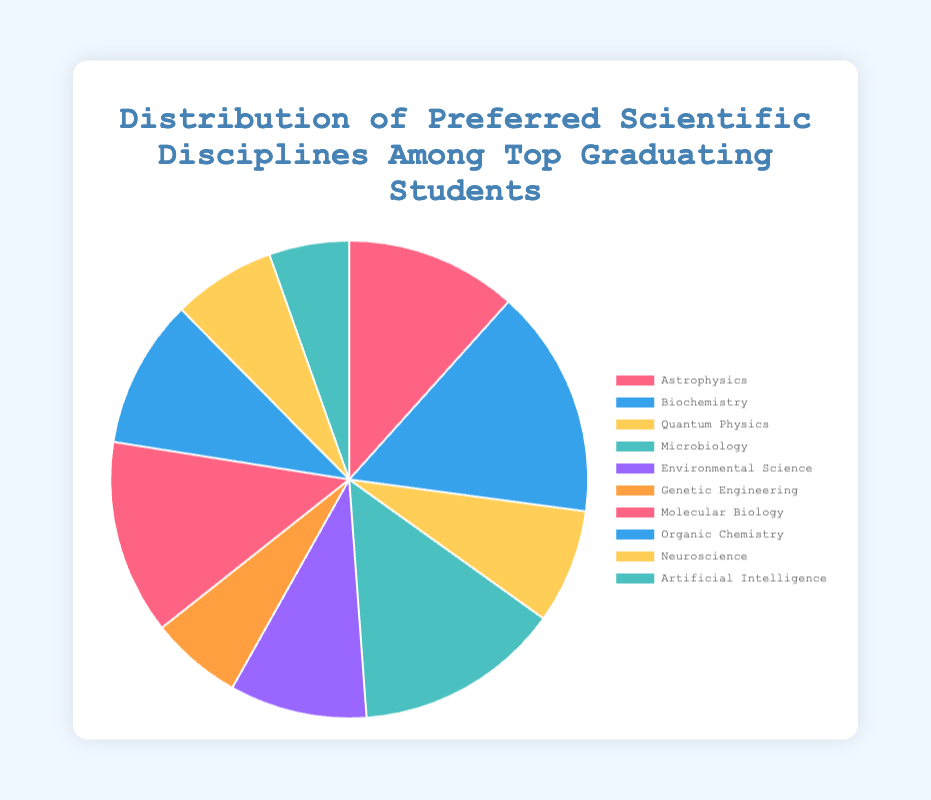Which scientific discipline has the largest number of top graduating students? Look at the pie chart to see which segment is the largest. The largest segment corresponds to Biochemistry with 20 top graduating students.
Answer: Biochemistry How many more students prefer Biochemistry over Astrophysics? Biochemistry has 20 students, and Astrophysics has 15. The difference is 20 - 15 = 5 students.
Answer: 5 What is the total number of top graduating students in Quantum Physics, Genetic Engineering, and Artificial Intelligence combined? Sum the number of students in these disciplines: Quantum Physics (10), Genetic Engineering (8), Artificial Intelligence (7). The total is 10 + 8 + 7 = 25 students.
Answer: 25 Which discipline has the smallest number of top graduating students? Identify the smallest segment on the pie chart. The smallest segment corresponds to Artificial Intelligence with 7 students.
Answer: Artificial Intelligence How many students prefer Environmental Science and Molecular Biology together? Add the number of students in Environmental Science (12) and Molecular Biology (17). The total is 12 + 17 = 29 students.
Answer: 29 Is the number of students in Microbiology greater or less than the number in Organic Chemistry? Compare the number of students in both disciplines: Microbiology (18) and Organic Chemistry (13). Microbiology has more students than Organic Chemistry.
Answer: Greater What percentage of the total do top graduating students in Neuroscience represent? Calculate the percentage: Neuroscience has 9 students out of a total of 129 (sum of all students in the chart). The percentage is (9 / 129) * 100 ≈ 6.98%.
Answer: Approximately 6.98% If Genetic Engineering and Artificial Intelligence were combined into one discipline, would it have more top graduating students than Molecular Biology? Combine the numbers: Genetic Engineering (8) + Artificial Intelligence (7) = 15; Molecular Biology has 17. Therefore, 15 < 17, so no, it would have fewer students.
Answer: No What is the difference in the number of top graduating students between Astrophysics and Molecular Biology? Calculate the difference: Astrophysics (15) and Molecular Biology (17). The difference is 17 - 15 = 2 students.
Answer: 2 Which two disciplines have a combined total number of top graduating students closest to 30? Look at the combinations: Microbiology (18) + Organic Chemistry (13) = 31, Environmental Science (12) + Molecular Biology (17) = 29. Since 29 is closest to 30, the disciplines are Environmental Science and Molecular Biology.
Answer: Environmental Science and Molecular Biology 